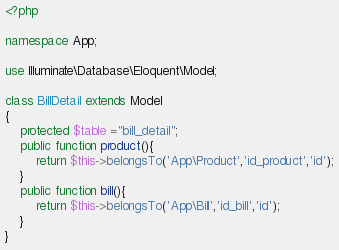<code> <loc_0><loc_0><loc_500><loc_500><_PHP_><?php

namespace App;

use Illuminate\Database\Eloquent\Model;

class BillDetail extends Model
{
    protected $table ="bill_detail";
    public function product(){
    	return $this->belongsTo('App\Product','id_product','id');
    }
    public function bill(){
    	return $this->belongsTo('App\Bill','id_bill','id');
    }
}
</code> 